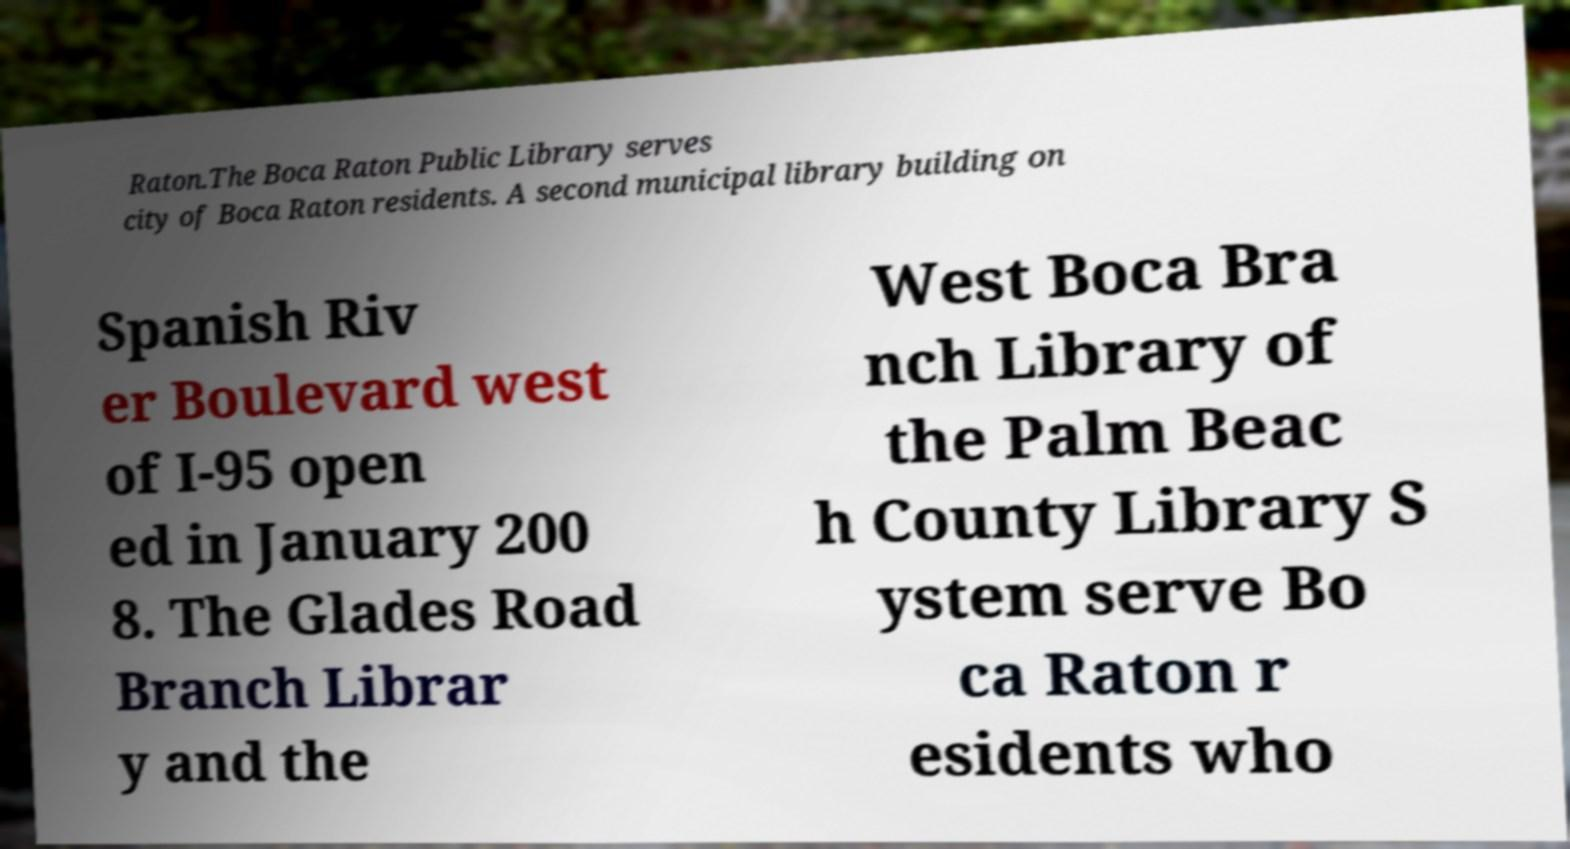Could you extract and type out the text from this image? Raton.The Boca Raton Public Library serves city of Boca Raton residents. A second municipal library building on Spanish Riv er Boulevard west of I-95 open ed in January 200 8. The Glades Road Branch Librar y and the West Boca Bra nch Library of the Palm Beac h County Library S ystem serve Bo ca Raton r esidents who 